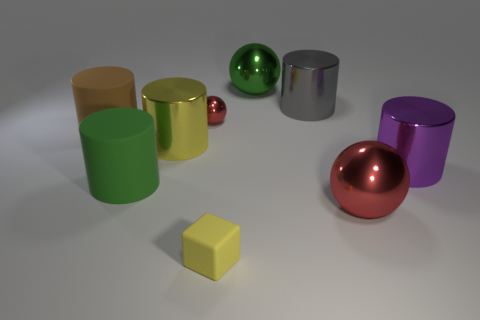The metal thing that is the same color as the small metallic sphere is what shape?
Offer a very short reply. Sphere. There is a big object that is the same color as the tiny matte object; what is its material?
Give a very brief answer. Metal. What is the material of the yellow block?
Offer a terse response. Rubber. What number of other objects are the same color as the small rubber thing?
Give a very brief answer. 1. Do the small block and the small shiny ball have the same color?
Provide a succinct answer. No. How many tiny things are there?
Your answer should be compact. 2. What is the material of the large green thing that is left of the red shiny sphere that is behind the brown rubber object?
Offer a very short reply. Rubber. There is a red sphere that is the same size as the green ball; what is its material?
Offer a very short reply. Metal. There is a brown cylinder in front of the gray metal object; does it have the same size as the big green metal thing?
Your answer should be compact. Yes. Does the matte object to the right of the yellow cylinder have the same shape as the gray thing?
Provide a short and direct response. No. 